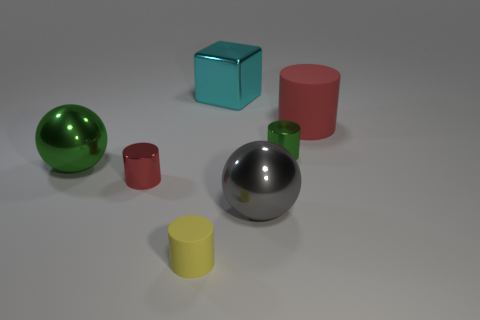Add 2 yellow rubber things. How many objects exist? 9 Subtract all balls. How many objects are left? 5 Subtract 1 yellow cylinders. How many objects are left? 6 Subtract all cyan objects. Subtract all red metal objects. How many objects are left? 5 Add 2 gray things. How many gray things are left? 3 Add 1 big gray metallic objects. How many big gray metallic objects exist? 2 